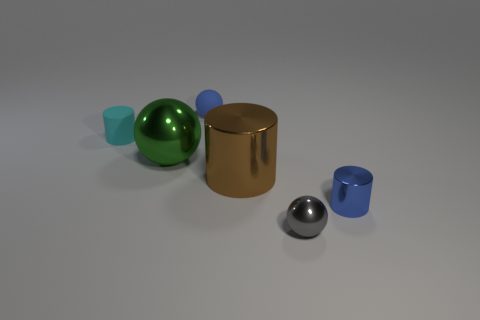Are the tiny cyan cylinder and the blue cylinder made of the same material?
Make the answer very short. No. The tiny object that is made of the same material as the blue ball is what color?
Keep it short and to the point. Cyan. How many tiny objects are either brown shiny things or cyan rubber cylinders?
Ensure brevity in your answer.  1. What number of brown metallic cylinders are right of the tiny metallic sphere?
Your response must be concise. 0. What is the color of the other shiny thing that is the same shape as the green metallic object?
Ensure brevity in your answer.  Gray. What number of rubber objects are purple cubes or balls?
Your answer should be very brief. 1. There is a small shiny cylinder that is behind the small gray ball in front of the large brown metal cylinder; is there a gray shiny ball that is on the left side of it?
Keep it short and to the point. Yes. What is the color of the tiny metal ball?
Give a very brief answer. Gray. There is a tiny cyan matte thing behind the large brown metal object; is its shape the same as the blue shiny object?
Give a very brief answer. Yes. What number of things are tiny rubber balls or tiny shiny objects that are to the left of the blue metal cylinder?
Your answer should be compact. 2. 